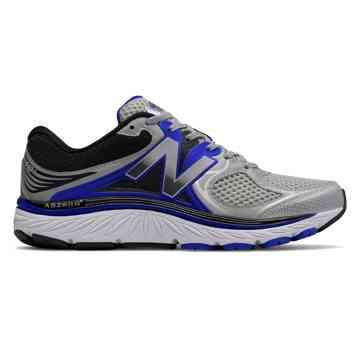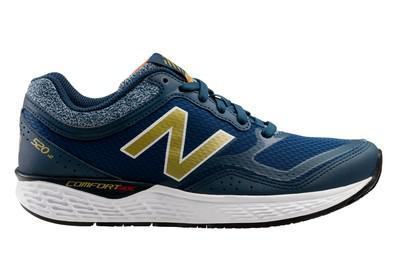The first image is the image on the left, the second image is the image on the right. For the images shown, is this caption "Exactly one shoe has a blue heel." true? Answer yes or no. No. 